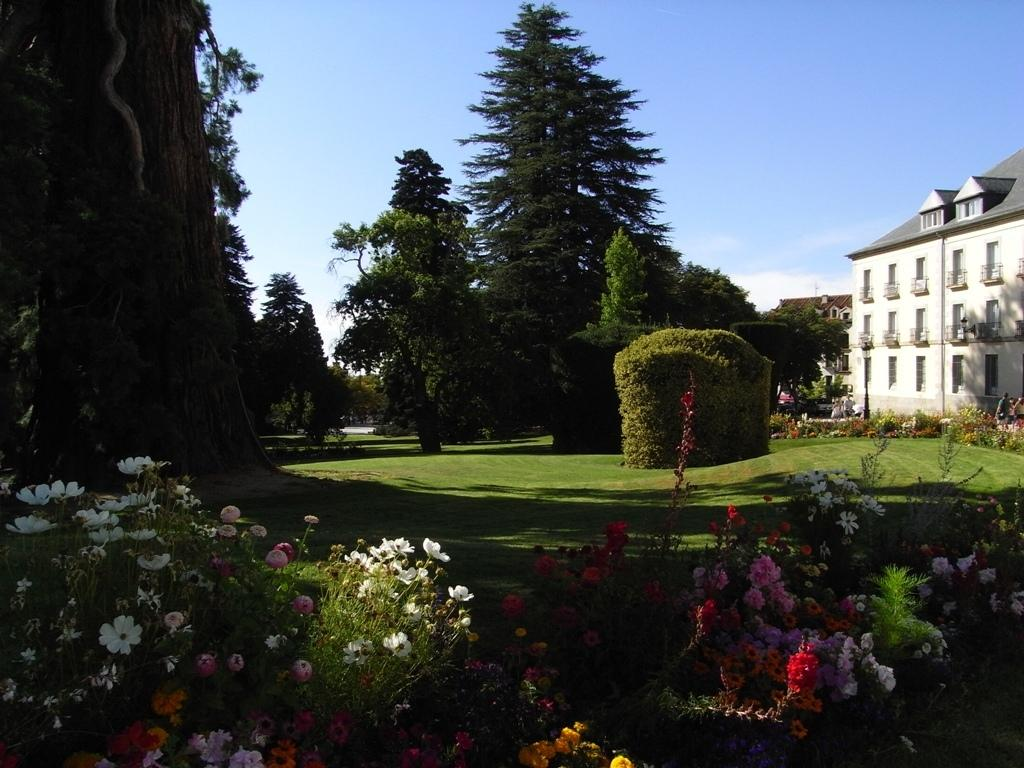What type of structures can be seen in the image? There are buildings in the image. What type of vegetation is present in the image? Garden plants, trees, and flowers are present in the image. What type of ground cover is visible in the image? Grass is visible in the image. What part of the natural environment is visible in the image? The sky is visible in the image. What type of current can be seen flowing through the veins of the sticks in the image? There are no sticks or veins present in the image. 